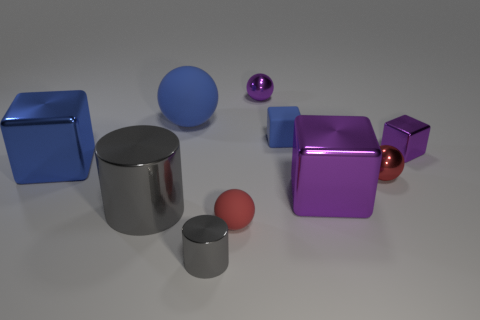There is a small shiny object behind the small blue rubber block; what color is it?
Keep it short and to the point. Purple. Is the number of blue spheres right of the large blue metallic thing greater than the number of large gray cubes?
Your answer should be compact. Yes. There is a red object that is to the left of the large purple cube; is it the same shape as the large matte thing?
Provide a succinct answer. Yes. What number of red objects are either tiny things or rubber blocks?
Your answer should be very brief. 2. Is the number of tiny gray objects greater than the number of big gray balls?
Offer a very short reply. Yes. There is a metal cylinder that is the same size as the blue rubber ball; what is its color?
Offer a terse response. Gray. How many balls are either small gray shiny objects or large brown shiny things?
Give a very brief answer. 0. Does the large blue rubber object have the same shape as the small metallic thing behind the matte cube?
Offer a very short reply. Yes. What number of other rubber cubes have the same size as the rubber block?
Make the answer very short. 0. There is a gray object that is on the right side of the large gray thing; is its shape the same as the gray metal object left of the big blue matte object?
Keep it short and to the point. Yes. 